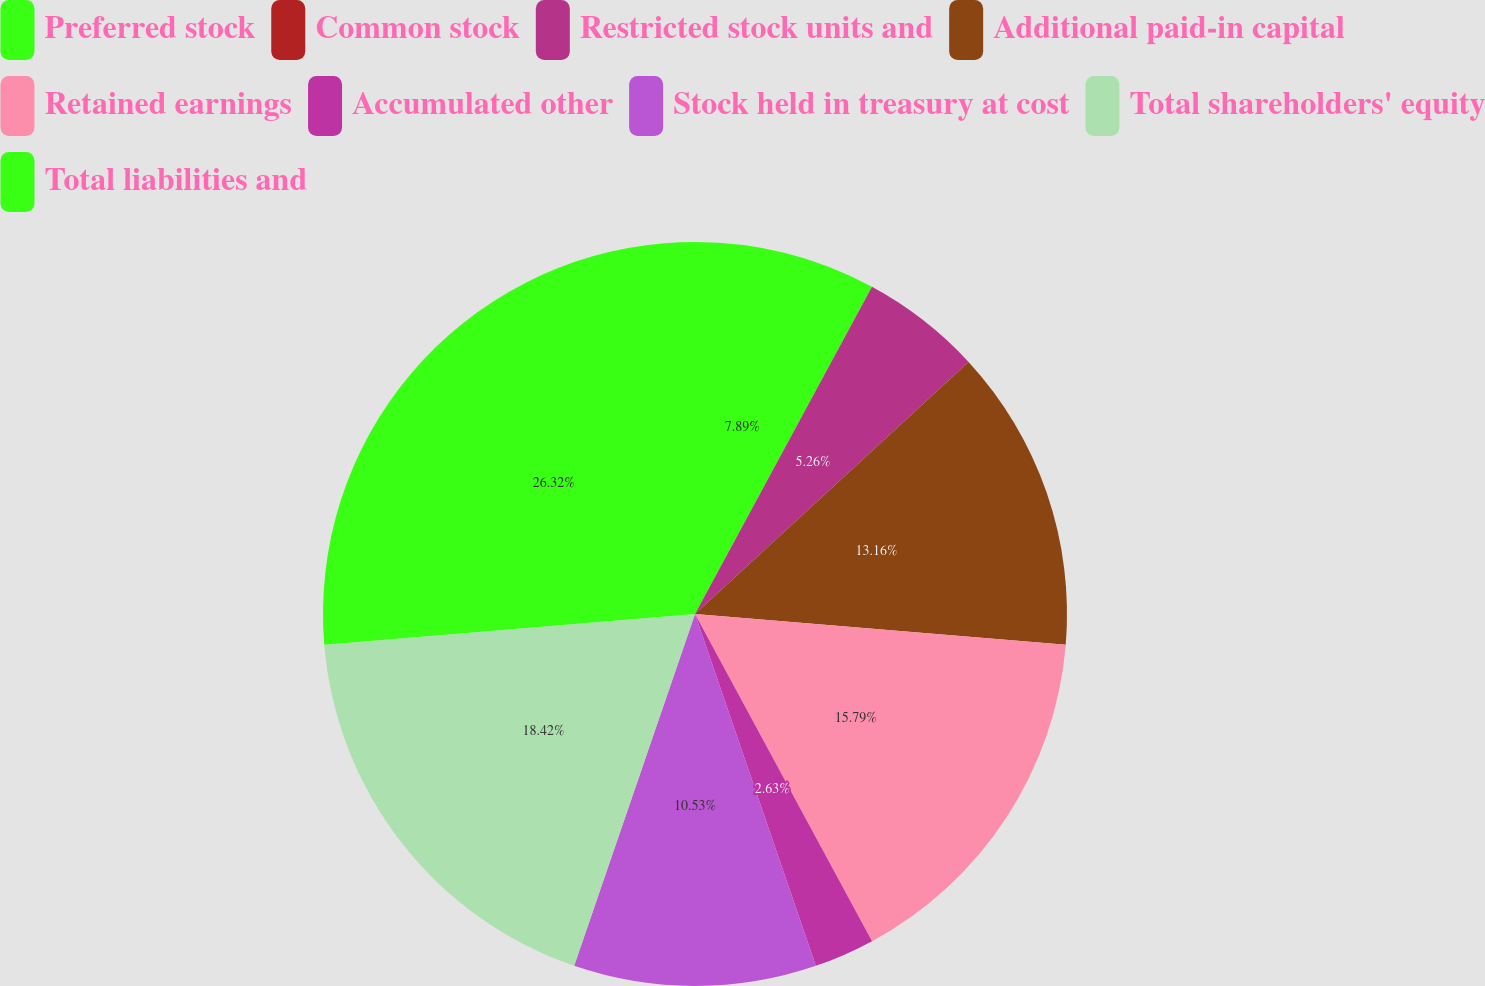<chart> <loc_0><loc_0><loc_500><loc_500><pie_chart><fcel>Preferred stock<fcel>Common stock<fcel>Restricted stock units and<fcel>Additional paid-in capital<fcel>Retained earnings<fcel>Accumulated other<fcel>Stock held in treasury at cost<fcel>Total shareholders' equity<fcel>Total liabilities and<nl><fcel>7.89%<fcel>0.0%<fcel>5.26%<fcel>13.16%<fcel>15.79%<fcel>2.63%<fcel>10.53%<fcel>18.42%<fcel>26.31%<nl></chart> 